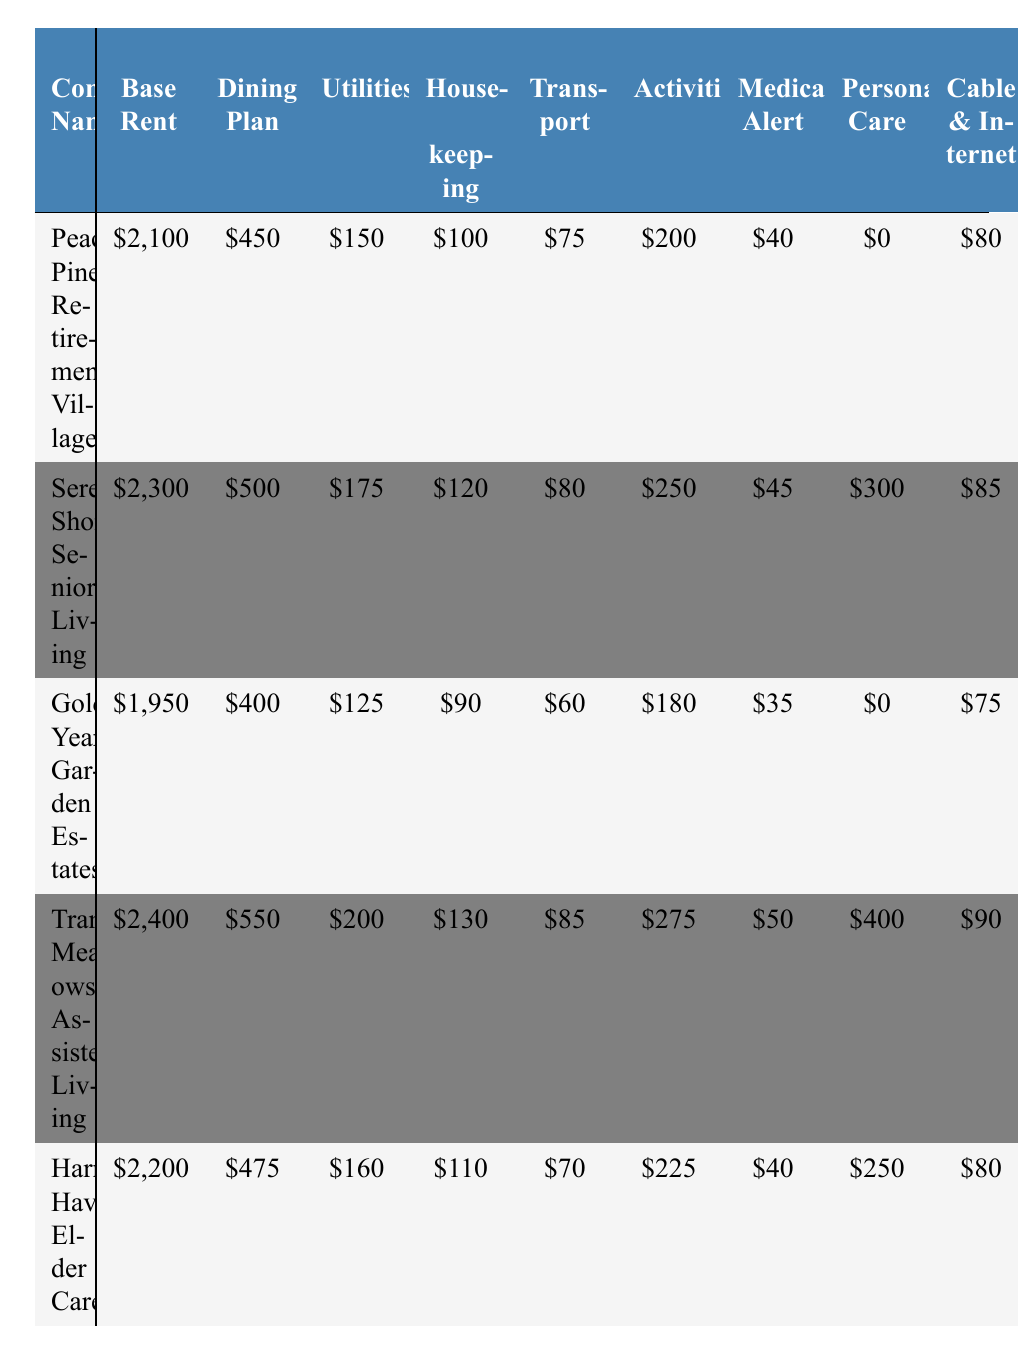What is the base rent for Tranquil Meadows Assisted Living? The table shows that the base rent for Tranquil Meadows Assisted Living is listed under that community's row, which indicates a value of $2,400.
Answer: $2,400 Which community has the highest dining plan cost? By examining the dining plan values for each community, Serene Shores Senior Living has the highest dining plan at $500.
Answer: Serene Shores Senior Living What is the total cost for each community including all expenses? To find the total expenses for each community, sum all the values in each row. For example, for Peaceful Pines Retirement Village: $2100 + $450 + $150 + $100 + $75 + $200 + $40 + $0 + $80 + $30 + $100 = $3,425. If detailed for all, the totals can be found systematically.
Answer: The total for Peaceful Pines is $3,425 Is there a community with no personal care services? Looking specifically at the personal care services column, both Peaceful Pines Retirement Village and Golden Years Garden Estates have a value of $0, indicating no personal care services are offered at these communities.
Answer: Yes What is the average maintenance fee across all communities? To calculate the average maintenance fee, add all the maintenance fees together (100 + 110 + 90 + 120 + 105 = 525) and divide by the number of communities (5). Thus, the average maintenance fee is 525/5 = 105.
Answer: $105 Which two communities have the lowest total utility expenses? By examining the utility expenses, Golden Years Garden Estates has $125 and Peaceful Pines Retirement Village has $150. Comparing these two, Golden Years Garden Estates has the lowest utility expense. Thus, they are the lowest together.
Answer: Golden Years Garden Estates and Peaceful Pines Retirement Village How much more is the total expense for Tranquil Meadows compared to Golden Years? First, calculate the total expense for each community: Tranquil Meadows is $2,400 + $550 + $200 + $130 + $85 + $275 + $50 + $400 + $90 + $40 + $120 = $4,440. Golden Years is $1,950 + $400 + $125 + $90 + $60 + $180 + $35 + $0 + $75 + $25 + $90 = $3,110. The difference is $4,440 - $3,110 = $1,330.
Answer: $1,330 Which community has the lowest overall expenses when personal care services are included? Add personal care services to the total for each community, then compare. For instance, Peaceful Pines = $3,425, Serene Shores = $4,110, Golden Years = $3,270, Tranquil Meadows = $4,840, Harmony Haven = $3,575. The lowest total is for Golden Years Garden Estates at $3,270.
Answer: Golden Years Garden Estates 